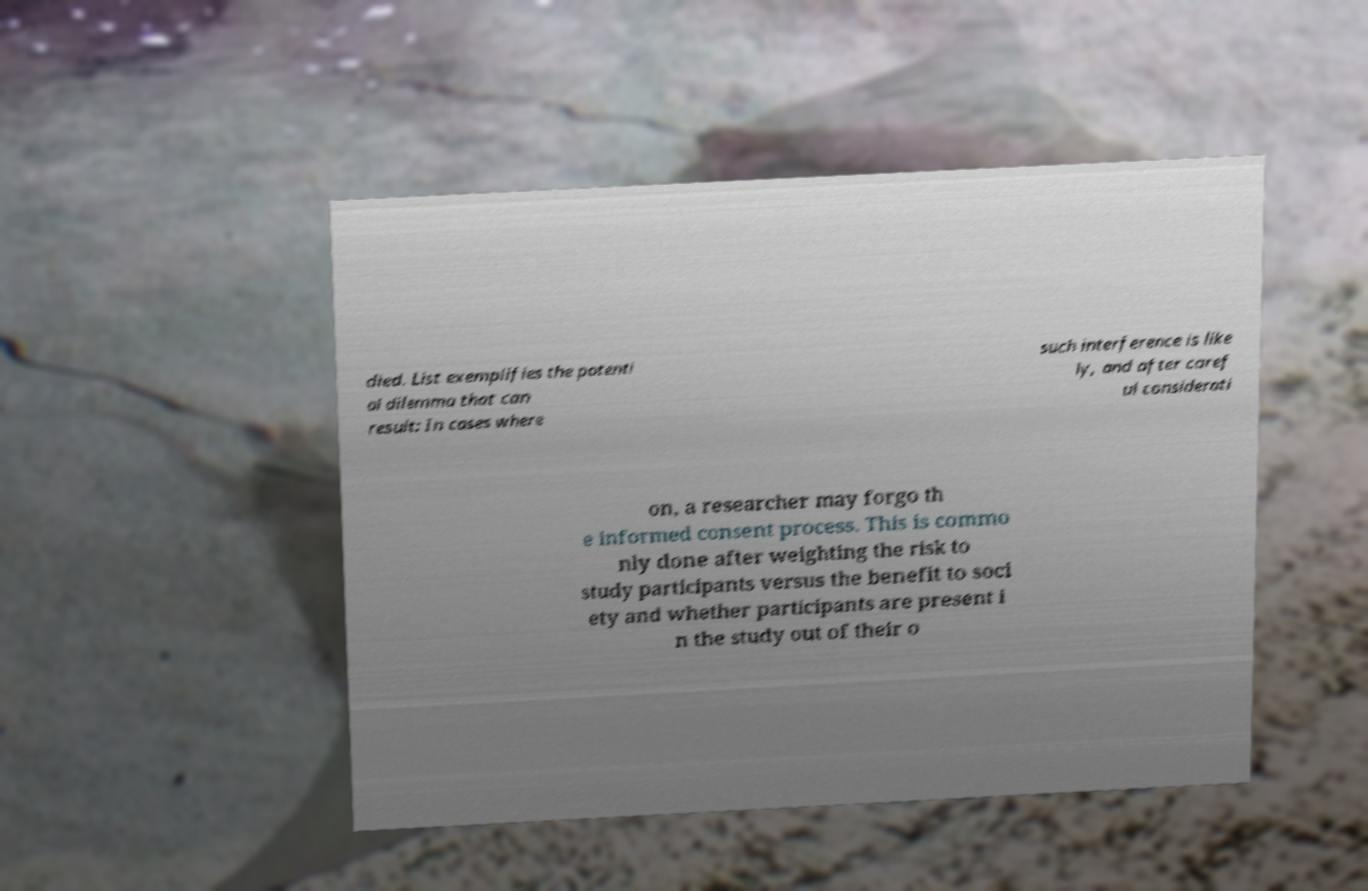For documentation purposes, I need the text within this image transcribed. Could you provide that? died. List exemplifies the potenti al dilemma that can result: In cases where such interference is like ly, and after caref ul considerati on, a researcher may forgo th e informed consent process. This is commo nly done after weighting the risk to study participants versus the benefit to soci ety and whether participants are present i n the study out of their o 